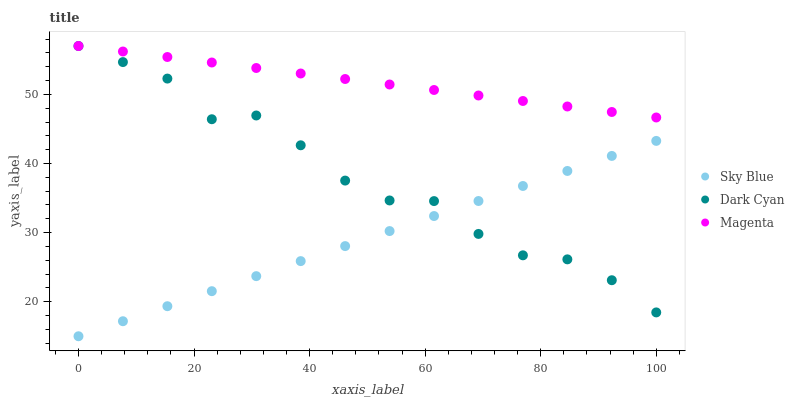Does Sky Blue have the minimum area under the curve?
Answer yes or no. Yes. Does Magenta have the maximum area under the curve?
Answer yes or no. Yes. Does Magenta have the minimum area under the curve?
Answer yes or no. No. Does Sky Blue have the maximum area under the curve?
Answer yes or no. No. Is Sky Blue the smoothest?
Answer yes or no. Yes. Is Dark Cyan the roughest?
Answer yes or no. Yes. Is Magenta the smoothest?
Answer yes or no. No. Is Magenta the roughest?
Answer yes or no. No. Does Sky Blue have the lowest value?
Answer yes or no. Yes. Does Magenta have the lowest value?
Answer yes or no. No. Does Magenta have the highest value?
Answer yes or no. Yes. Does Sky Blue have the highest value?
Answer yes or no. No. Is Sky Blue less than Magenta?
Answer yes or no. Yes. Is Magenta greater than Sky Blue?
Answer yes or no. Yes. Does Dark Cyan intersect Sky Blue?
Answer yes or no. Yes. Is Dark Cyan less than Sky Blue?
Answer yes or no. No. Is Dark Cyan greater than Sky Blue?
Answer yes or no. No. Does Sky Blue intersect Magenta?
Answer yes or no. No. 